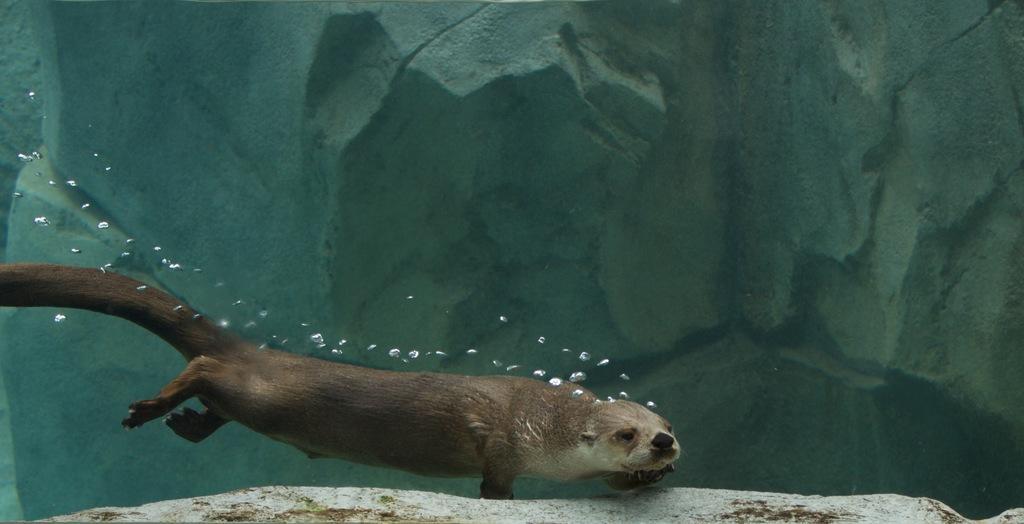Could you give a brief overview of what you see in this image? In the water we can see an animal. 